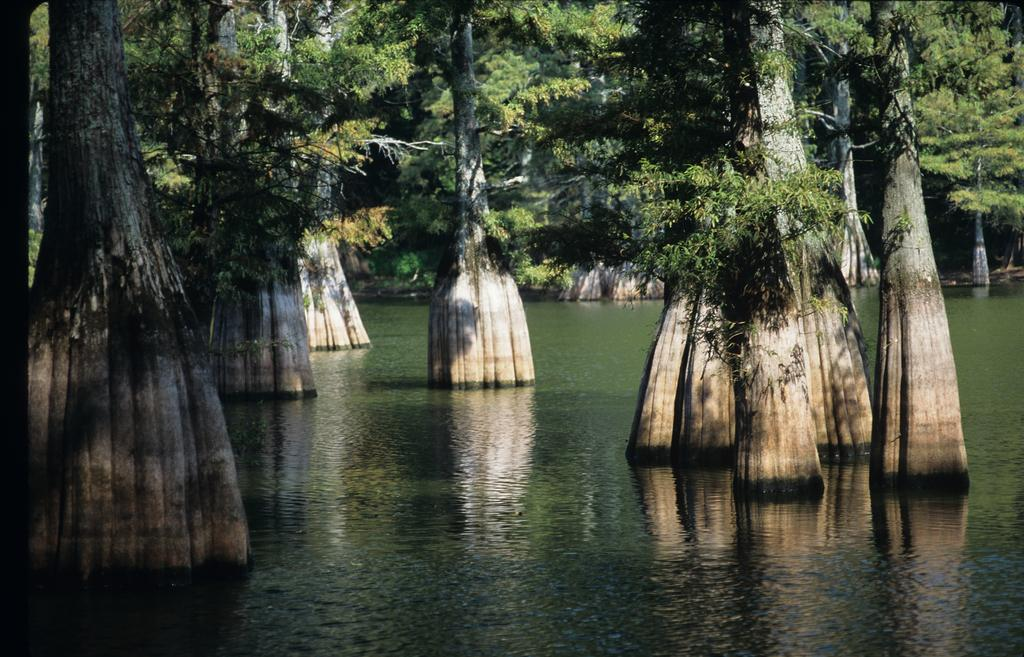What is the primary element visible in the image? There is water in the image. What can be seen within the water? There are trees in the water. How do the trees appear in the water? The trees have huge trunks. What type of boundary can be seen surrounding the trees in the image? There is no boundary visible around the trees in the image. What material is the coat made of that the trees are wearing in the image? There are no trees wearing coats in the image. 